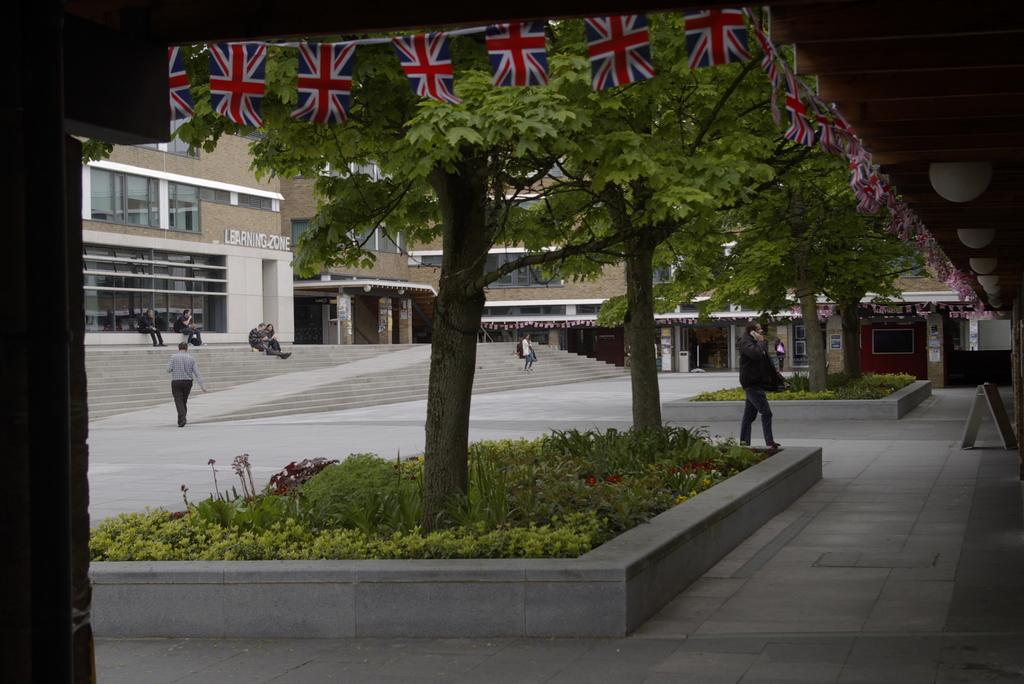What type of structures are visible in the image? There are buildings in the image. What other natural elements can be seen in the image? There are trees and plants in the image. What are some of the activities people are engaged in within the image? People are sitting on stairs and walking in the image. What is the surface that the people and buildings are situated on? There is a floor at the bottom of the image. Can you hear the sound of a horn in the image? There is no mention of a horn or any sound in the image, so it cannot be determined whether a horn is present or not. Are there any dinosaurs visible in the image? There are no dinosaurs present in the image; it features buildings, trees, plants, and people. 